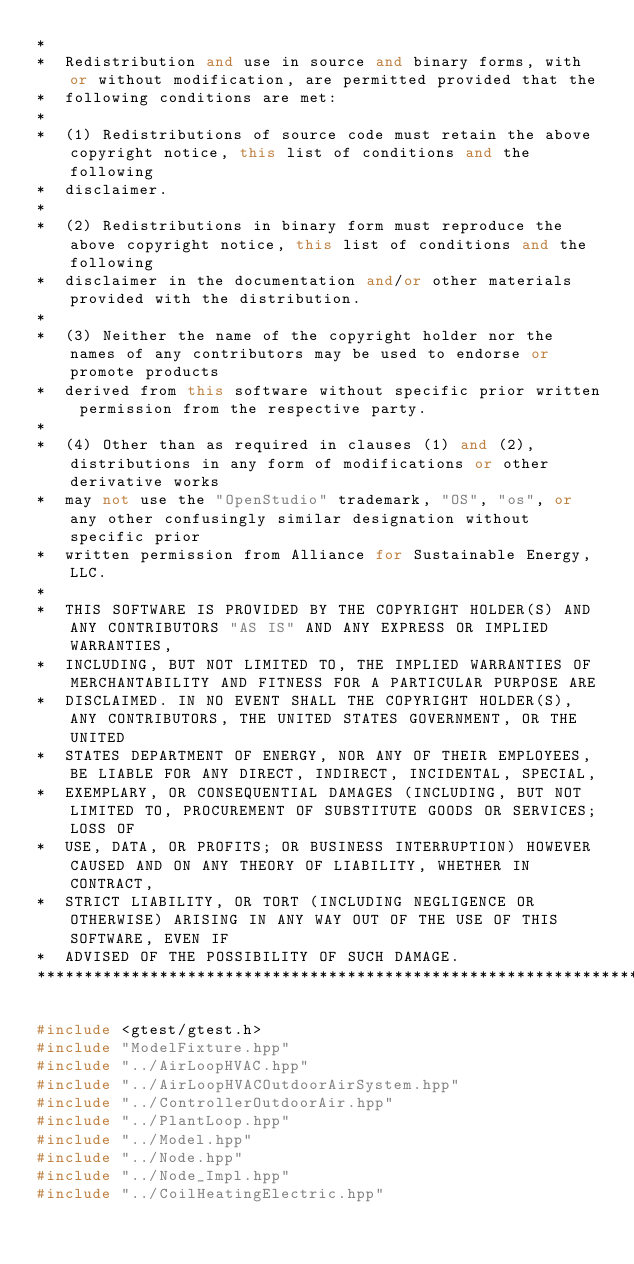<code> <loc_0><loc_0><loc_500><loc_500><_C++_>*
*  Redistribution and use in source and binary forms, with or without modification, are permitted provided that the
*  following conditions are met:
*
*  (1) Redistributions of source code must retain the above copyright notice, this list of conditions and the following
*  disclaimer.
*
*  (2) Redistributions in binary form must reproduce the above copyright notice, this list of conditions and the following
*  disclaimer in the documentation and/or other materials provided with the distribution.
*
*  (3) Neither the name of the copyright holder nor the names of any contributors may be used to endorse or promote products
*  derived from this software without specific prior written permission from the respective party.
*
*  (4) Other than as required in clauses (1) and (2), distributions in any form of modifications or other derivative works
*  may not use the "OpenStudio" trademark, "OS", "os", or any other confusingly similar designation without specific prior
*  written permission from Alliance for Sustainable Energy, LLC.
*
*  THIS SOFTWARE IS PROVIDED BY THE COPYRIGHT HOLDER(S) AND ANY CONTRIBUTORS "AS IS" AND ANY EXPRESS OR IMPLIED WARRANTIES,
*  INCLUDING, BUT NOT LIMITED TO, THE IMPLIED WARRANTIES OF MERCHANTABILITY AND FITNESS FOR A PARTICULAR PURPOSE ARE
*  DISCLAIMED. IN NO EVENT SHALL THE COPYRIGHT HOLDER(S), ANY CONTRIBUTORS, THE UNITED STATES GOVERNMENT, OR THE UNITED
*  STATES DEPARTMENT OF ENERGY, NOR ANY OF THEIR EMPLOYEES, BE LIABLE FOR ANY DIRECT, INDIRECT, INCIDENTAL, SPECIAL,
*  EXEMPLARY, OR CONSEQUENTIAL DAMAGES (INCLUDING, BUT NOT LIMITED TO, PROCUREMENT OF SUBSTITUTE GOODS OR SERVICES; LOSS OF
*  USE, DATA, OR PROFITS; OR BUSINESS INTERRUPTION) HOWEVER CAUSED AND ON ANY THEORY OF LIABILITY, WHETHER IN CONTRACT,
*  STRICT LIABILITY, OR TORT (INCLUDING NEGLIGENCE OR OTHERWISE) ARISING IN ANY WAY OUT OF THE USE OF THIS SOFTWARE, EVEN IF
*  ADVISED OF THE POSSIBILITY OF SUCH DAMAGE.
***********************************************************************************************************************/

#include <gtest/gtest.h>
#include "ModelFixture.hpp"
#include "../AirLoopHVAC.hpp"
#include "../AirLoopHVACOutdoorAirSystem.hpp"
#include "../ControllerOutdoorAir.hpp"
#include "../PlantLoop.hpp"
#include "../Model.hpp"
#include "../Node.hpp"
#include "../Node_Impl.hpp"
#include "../CoilHeatingElectric.hpp"</code> 